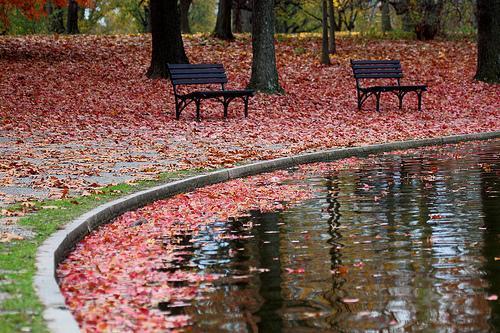How many benches are in this photo?
Give a very brief answer. 2. How many people are pictured here?
Give a very brief answer. 0. 